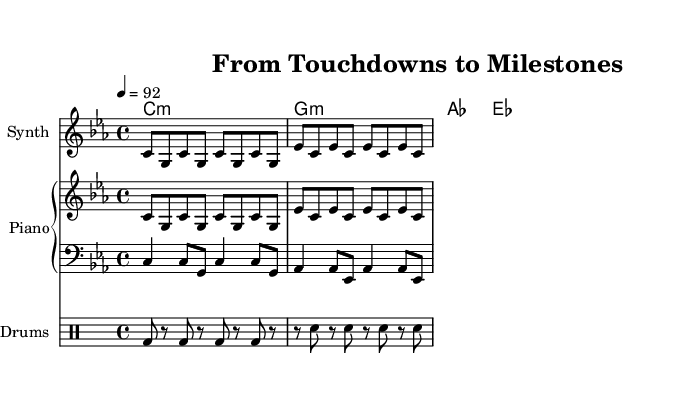What is the key signature of this music? The key signature is C minor, indicated by three flat signatures (B♭, E♭, A♭) shown before the staff.
Answer: C minor What is the time signature of this music? The time signature is 4/4, represented in the sheet music as a fraction at the beginning, indicating four beats per measure with a quarter note receiving one beat.
Answer: 4/4 What is the tempo marking for this piece? The tempo marking is 92 beats per minute, described at the beginning of the score with the notation "4 = 92," indicating the metronome setting.
Answer: 92 How many measures are present in the main hook? The main hook consists of 8 measures, as indicated by the repeated patterns in the music staff, with each group of notes representing one measure.
Answer: 8 What style is this music associated with? The music is associated with rap, which can be inferred from its rhythmic structure and instrumentation tailored for the genre, including drums and a synth.
Answer: Rap Which instrument is designated for the rhythm section in this score? The rhythm section is indicated by the drum staff, which specifies the drum pattern alongside the other instrumental sections, clarifying its role in the music.
Answer: Drums What type of chords are used in this piece? The chords used are minor chords, as indicated by the names shown in the chord names section, specifically denoted by the suffix "m" for minor.
Answer: Minor chords 